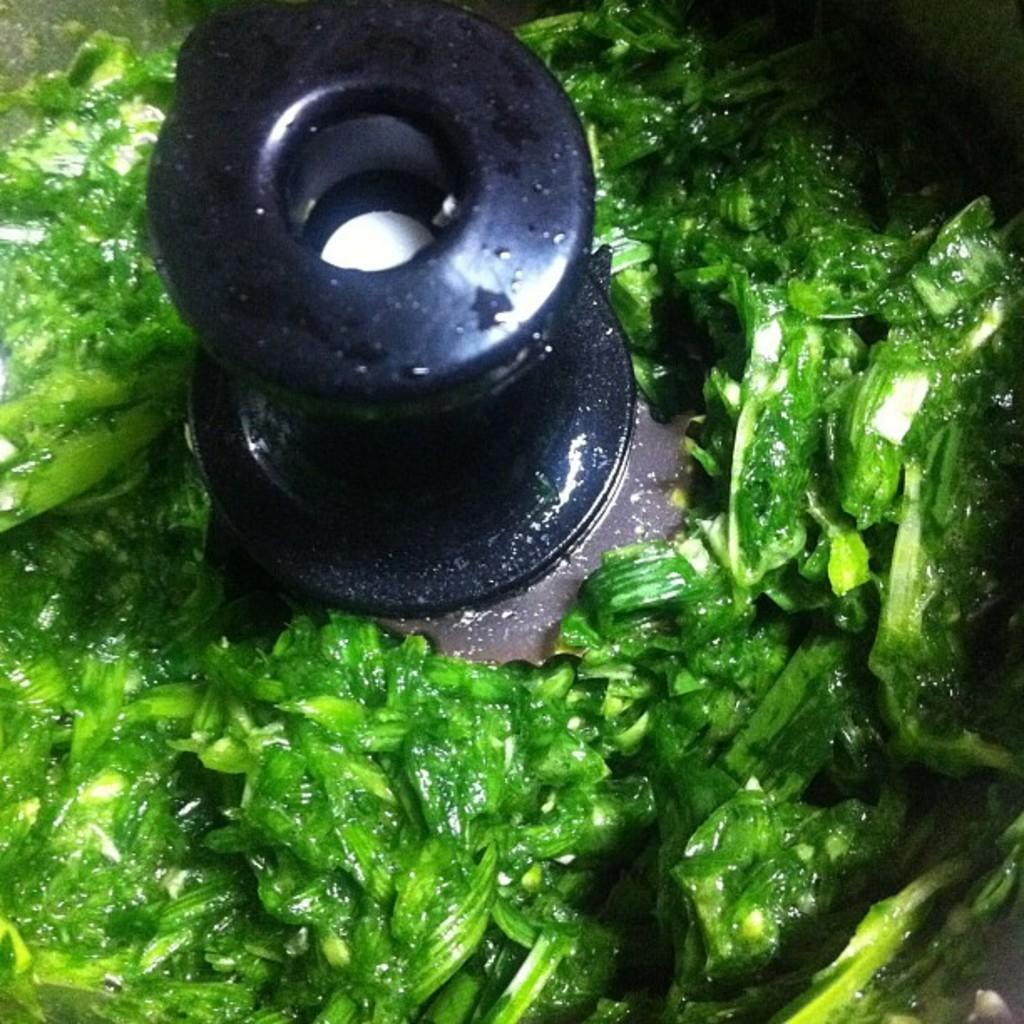What color is the food item in the image? The food item in the image has a green color. Where is the food item located in the image? The food item is in a mixer or a grinder. What type of ticket can be seen in the image? There is no ticket present in the image. 